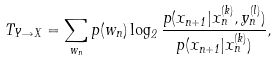<formula> <loc_0><loc_0><loc_500><loc_500>T _ { Y \rightarrow X } = \sum _ { w _ { n } } p ( w _ { n } ) \log _ { 2 } { \frac { p ( x _ { n + 1 } | x ^ { ( k ) } _ { n } , y ^ { ( l ) } _ { n } ) } { p ( x _ { n + 1 } | x ^ { ( k ) } _ { n } ) } } ,</formula> 